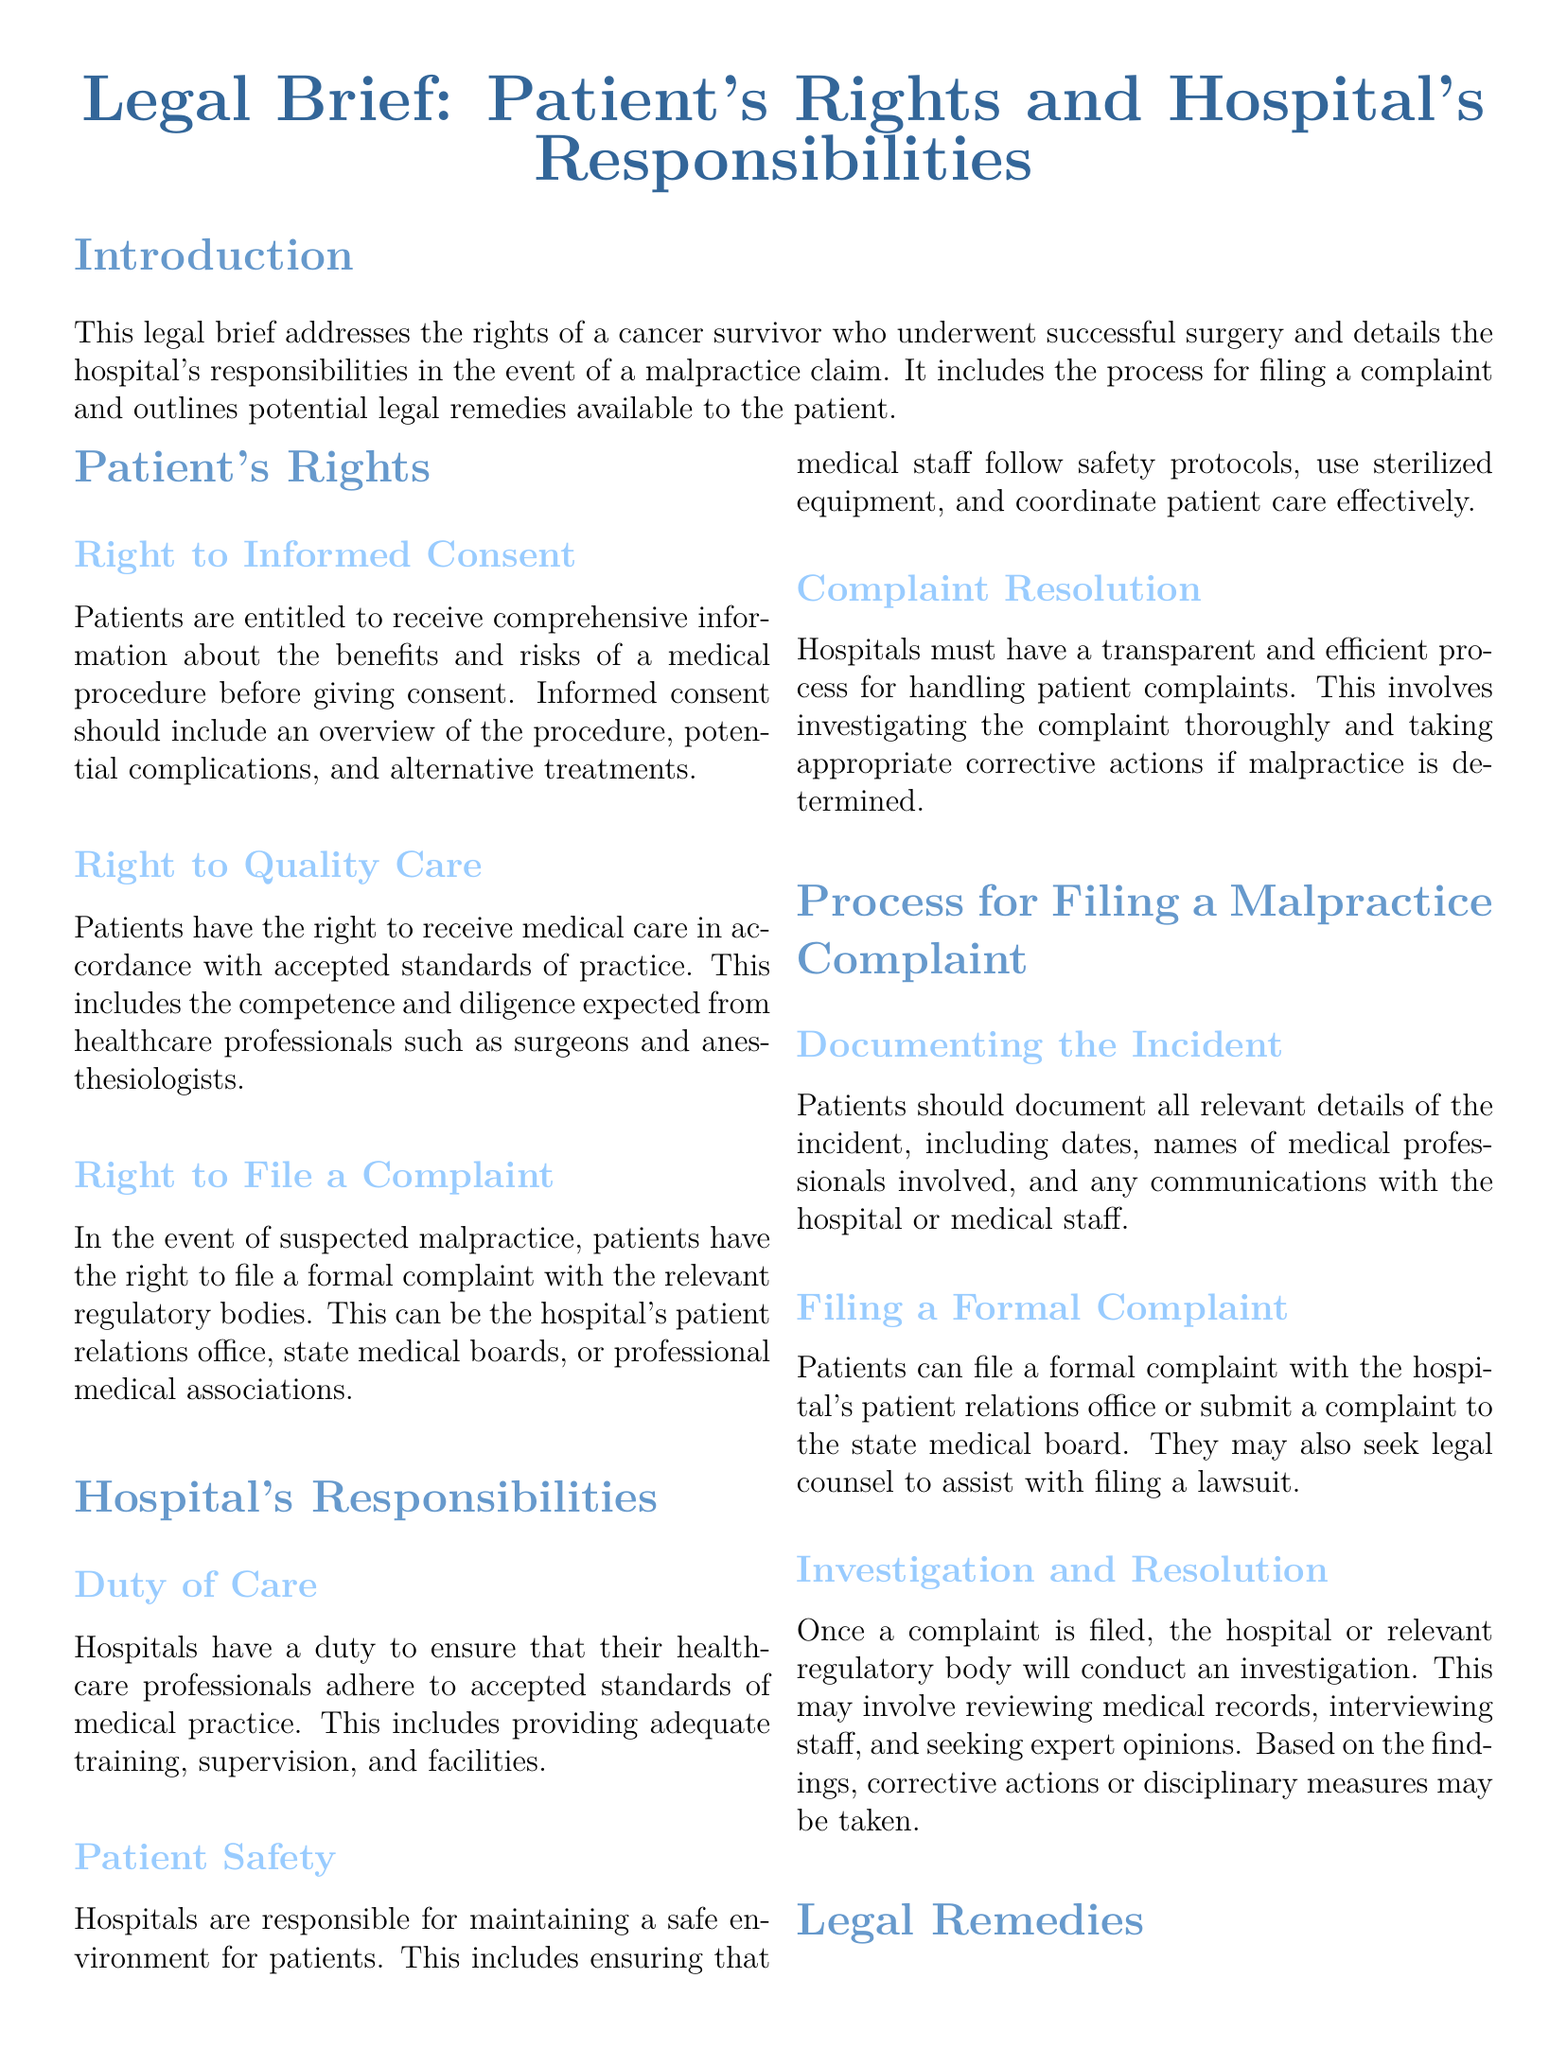What is the title of the legal brief? The title of the legal brief is found at the beginning of the document, highlighting the main topic addressed.
Answer: Legal Brief: Patient's Rights and Hospital's Responsibilities What is one right of patients mentioned in the document? The document lists specific rights that patients have, one of which is detailed under the "Patient's Rights" section.
Answer: Right to Informed Consent What is the hospital's duty regarding patient safety? The document outlines the responsibilities that hospitals have towards patient safety, emphasizing an obligation stated in the "Hospital's Responsibilities" section.
Answer: Maintain a safe environment What must a patient document when filing a malpractice complaint? Patients are advised to document details regarding their incident, as mentioned in the section on filing a complaint.
Answer: Relevant details of the incident What can a patient seek if malpractice is established? The document mentions certain outcomes for patients in the event of a successful malpractice claim.
Answer: Compensation for Damages Which body can a patient file a complaint with? The legal brief specifies organizations where patients can submit their complaints related to malpractice, reflecting various regulatory options.
Answer: State medical board What is one potential legal remedy listed in the document? The document details different legal remedies available to patients, revealing options for redress in case of malpractice.
Answer: Medical Malpractice Lawsuit How should hospitals address complaints according to this brief? The brief emphasizes protocols hospitals should follow to address patient complaints effectively and ensure resolution.
Answer: Transparent and efficient process What is necessary for informed consent according to the brief? The document describes the essential elements that must be included for obtaining informed consent from patients.
Answer: Comprehensive information about the procedure 